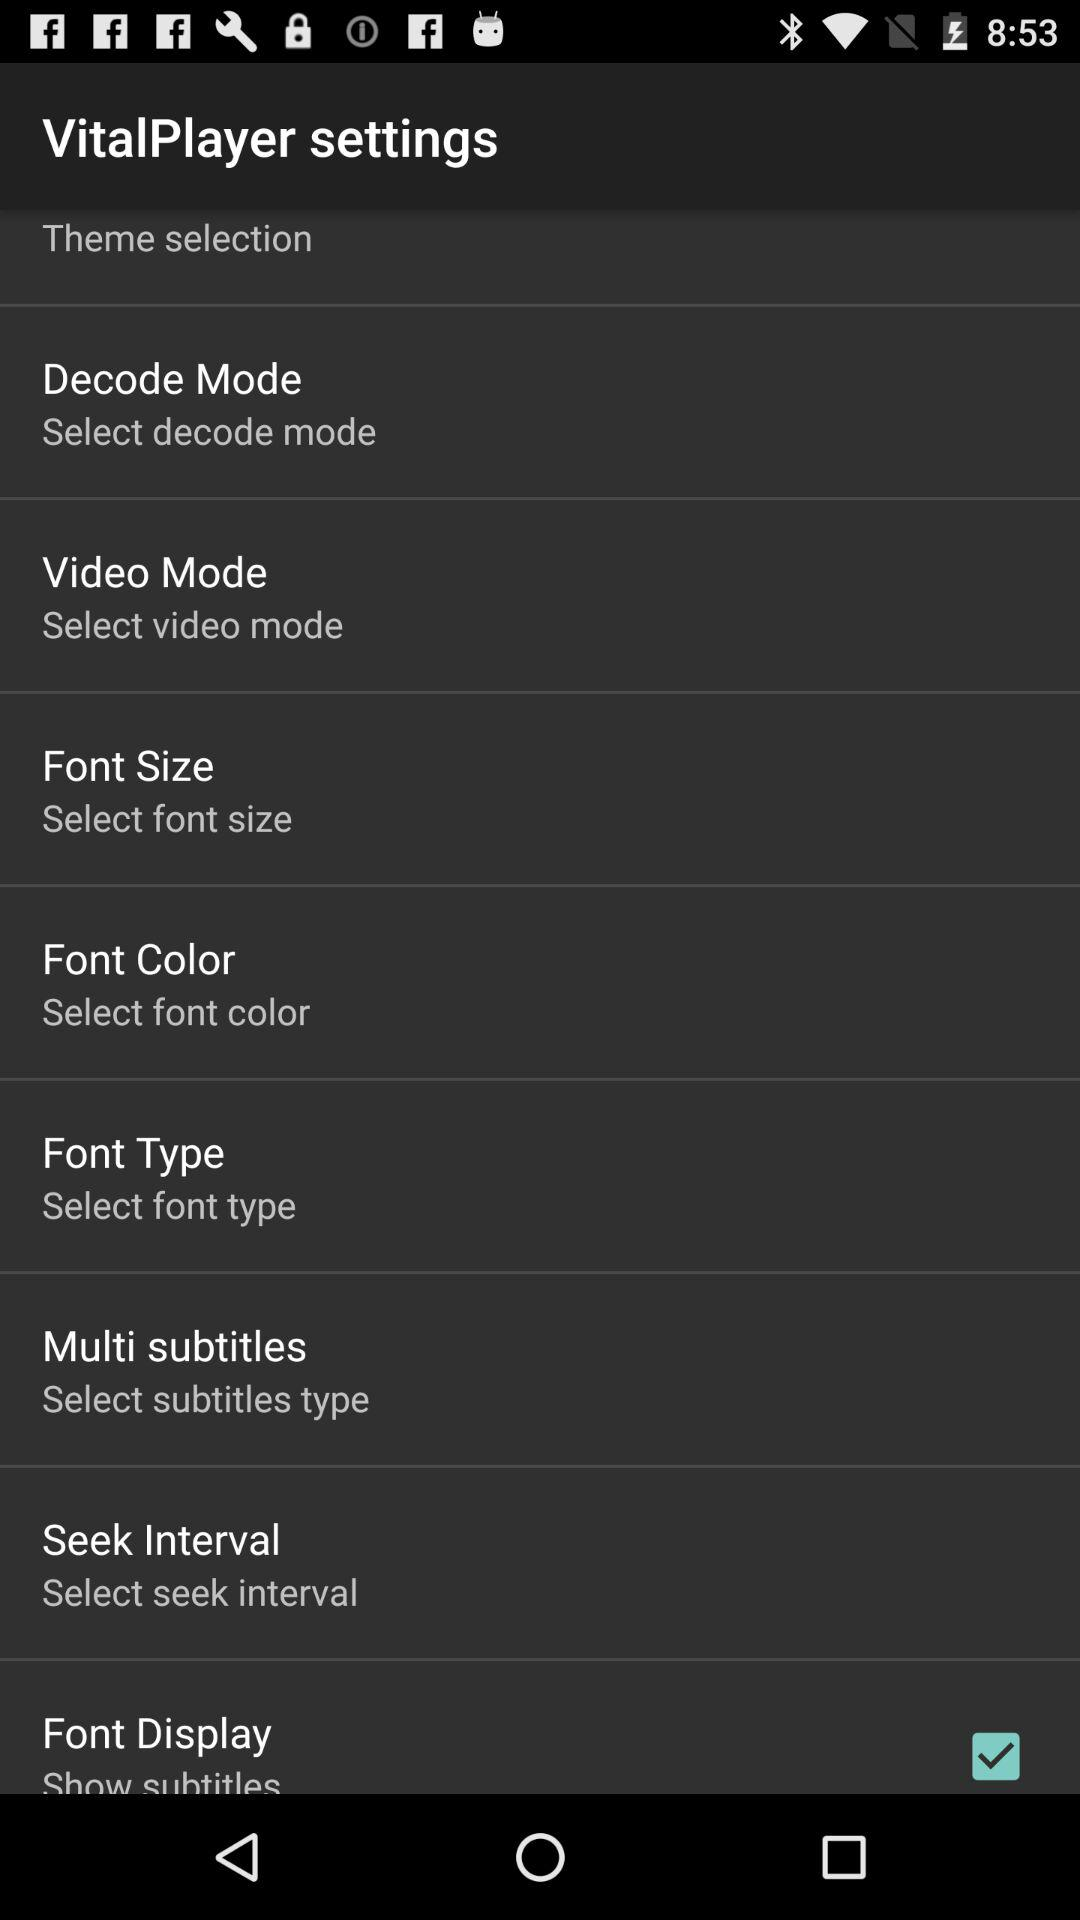What is the name of the application? The name of the application is "VitalPlayer". 